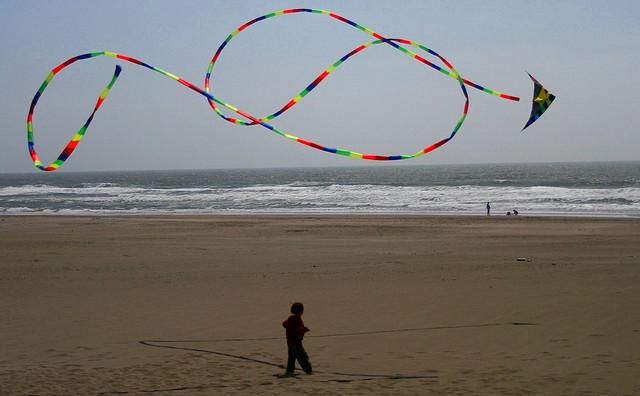What is unique about this kite?

Choices:
A) tail
B) height
C) size
D) style tail 